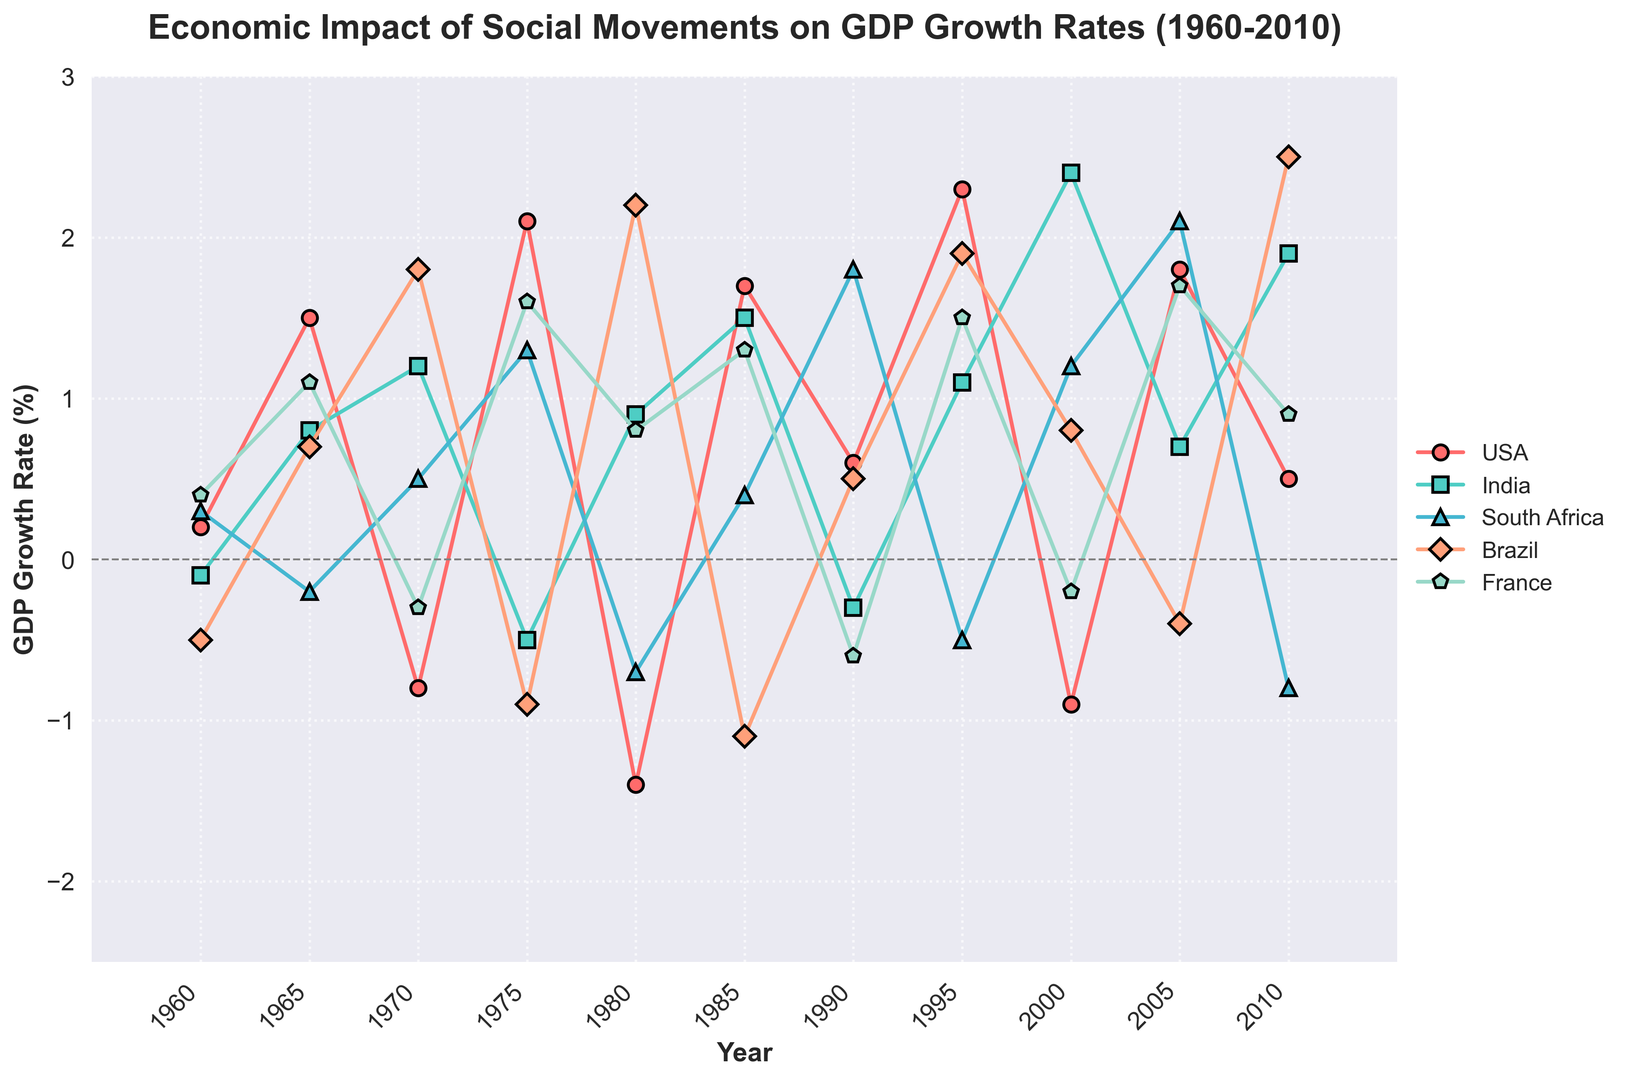Which country had the highest GDP growth rate in 1975? To find the highest GDP growth rate in 1975, compare the values for all countries: USA (2.1), India (-0.5), South Africa (1.3), Brazil (-0.9), France (1.6). The USA has the highest value.
Answer: USA Which country showed a consistent positive GDP growth rate from 2000 to 2010? To determine consistency, review the values for each country over the years 2000-2010: USA (-0.9, 1.8, 0.5), India (2.4, 0.7, 1.9), South Africa (1.2, 2.1, -0.8), Brazil (0.8, -0.4, 2.5), France (-0.2, 1.7, 0.9). Only India remains positive in all years.
Answer: India What is the average GDP growth rate for France across all the years listed? Compute the average by summing the France values (0.4, 1.1, -0.3, 1.6, 0.8, 1.3, -0.6, 1.5, -0.2, 1.7, 0.9) and dividing by the number of data points (11). The calculation: 0.4 + 1.1 - 0.3 + 1.6 + 0.8 + 1.3 - 0.6 + 1.5 - 0.2 + 1.7 + 0.9 = 8.2, and 8.2 / 11 ≈ 0.75.
Answer: 0.75 In which year did South Africa experience its largest negative GDP growth rate? Review South Africa's values for the most negative value: 1960 (0.3), 1965 (-0.2), 1970 (0.5), 1975 (1.3), 1980 (-0.7), 1985 (0.4), 1990 (1.8), 1995 (-0.5), 2000 (1.2), 2005 (2.1), 2010 (-0.8). The year 2010 has the most negative rate.
Answer: 2010 Which country had the highest cumulative GDP growth from 1960 to 1970? Calculate the cumulative growth for each country by summing the values from 1960, 1965, and 1970: USA (0.2 + 1.5 - 0.8 = 0.9), India (-0.1 + 0.8 + 1.2 = 1.9), South Africa (0.3 - 0.2 + 0.5 = 0.6), Brazil (-0.5 + 0.7 + 1.8 = 2.0), France (0.4 + 1.1 - 0.3 = 1.2). Brazil has the highest cumulative value.
Answer: Brazil During which year did Brazil experience its lowest GDP growth rate? Scan Brazil's values to find the most negative: 1960 (-0.5), 1965 (0.7), 1970 (1.8), 1975 (-0.9), 1980 (2.2), 1985 (-1.1), 1990 (0.5), 1995 (1.9), 2000 (0.8), 2005 (-0.4), 2010 (2.5). The lowest rate was in 1985.
Answer: 1985 